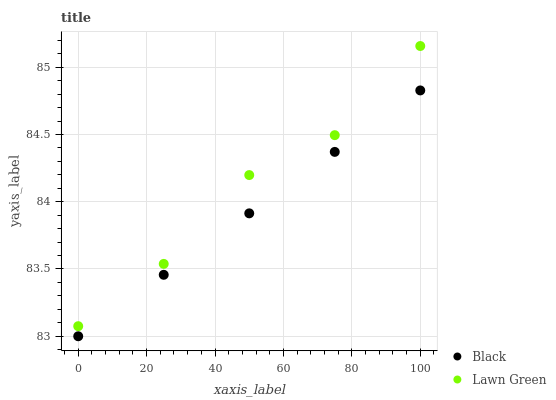Does Black have the minimum area under the curve?
Answer yes or no. Yes. Does Lawn Green have the maximum area under the curve?
Answer yes or no. Yes. Does Black have the maximum area under the curve?
Answer yes or no. No. Is Black the smoothest?
Answer yes or no. Yes. Is Lawn Green the roughest?
Answer yes or no. Yes. Is Black the roughest?
Answer yes or no. No. Does Black have the lowest value?
Answer yes or no. Yes. Does Lawn Green have the highest value?
Answer yes or no. Yes. Does Black have the highest value?
Answer yes or no. No. Is Black less than Lawn Green?
Answer yes or no. Yes. Is Lawn Green greater than Black?
Answer yes or no. Yes. Does Black intersect Lawn Green?
Answer yes or no. No. 